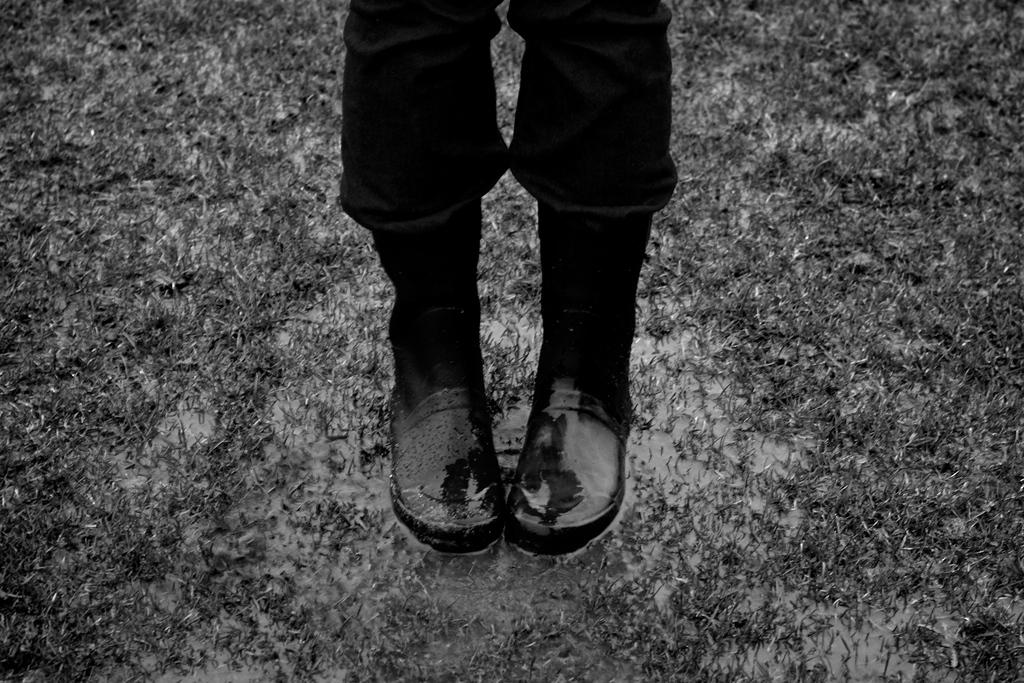What is the color scheme of the image? The image is black and white. What part of a person can be seen in the image? The legs of a person are visible in the image. What type of footwear is the person wearing? The person is wearing shoes. What type of terrain is present in the image? There is grass on the ground in the image. What natural element is visible in the image? There is water visible in the image. What type of seed is being planted in the image? There is no seed or planting activity present in the image. What time of day is depicted in the image? The image does not provide information about the time of day, as it is black and white. 